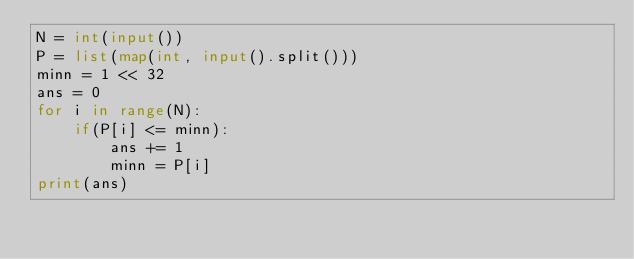Convert code to text. <code><loc_0><loc_0><loc_500><loc_500><_Python_>N = int(input())
P = list(map(int, input().split()))
minn = 1 << 32
ans = 0
for i in range(N):
    if(P[i] <= minn):
        ans += 1
        minn = P[i]
print(ans)</code> 